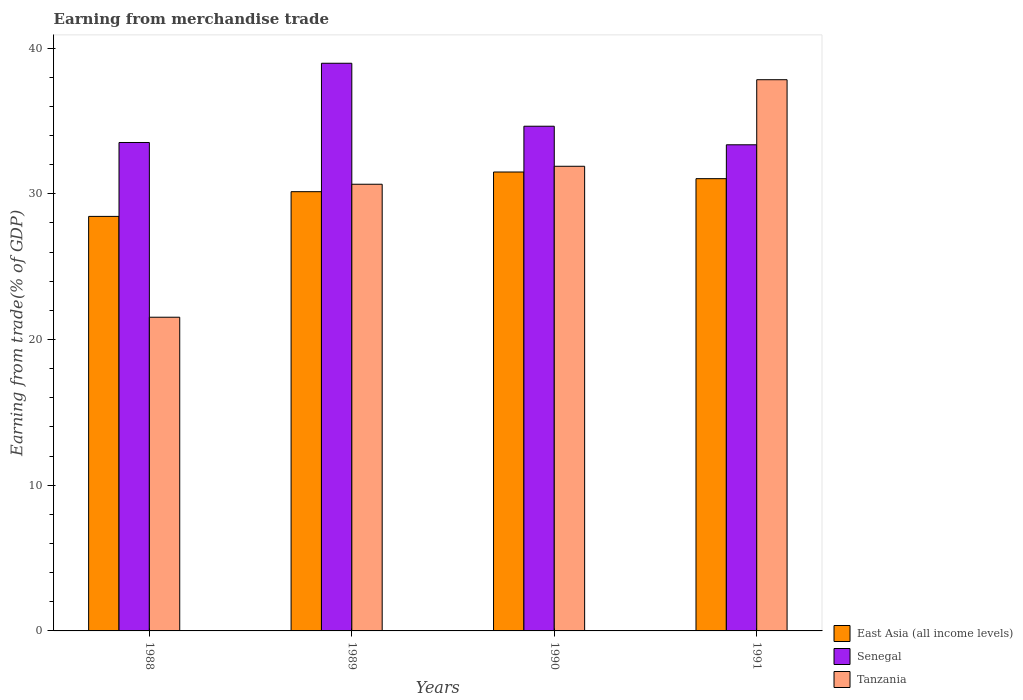How many different coloured bars are there?
Provide a succinct answer. 3. How many groups of bars are there?
Ensure brevity in your answer.  4. Are the number of bars per tick equal to the number of legend labels?
Your answer should be very brief. Yes. What is the earnings from trade in East Asia (all income levels) in 1991?
Ensure brevity in your answer.  31.04. Across all years, what is the maximum earnings from trade in East Asia (all income levels)?
Offer a terse response. 31.49. Across all years, what is the minimum earnings from trade in Tanzania?
Offer a terse response. 21.53. In which year was the earnings from trade in Senegal maximum?
Your answer should be very brief. 1989. What is the total earnings from trade in Senegal in the graph?
Offer a very short reply. 140.47. What is the difference between the earnings from trade in Senegal in 1988 and that in 1991?
Your answer should be compact. 0.16. What is the difference between the earnings from trade in Tanzania in 1991 and the earnings from trade in East Asia (all income levels) in 1990?
Your answer should be very brief. 6.33. What is the average earnings from trade in Senegal per year?
Your answer should be compact. 35.12. In the year 1988, what is the difference between the earnings from trade in East Asia (all income levels) and earnings from trade in Tanzania?
Make the answer very short. 6.92. What is the ratio of the earnings from trade in Senegal in 1988 to that in 1990?
Provide a short and direct response. 0.97. Is the difference between the earnings from trade in East Asia (all income levels) in 1988 and 1991 greater than the difference between the earnings from trade in Tanzania in 1988 and 1991?
Make the answer very short. Yes. What is the difference between the highest and the second highest earnings from trade in East Asia (all income levels)?
Your answer should be compact. 0.46. What is the difference between the highest and the lowest earnings from trade in Senegal?
Provide a succinct answer. 5.6. What does the 3rd bar from the left in 1988 represents?
Your response must be concise. Tanzania. What does the 3rd bar from the right in 1988 represents?
Ensure brevity in your answer.  East Asia (all income levels). Is it the case that in every year, the sum of the earnings from trade in Senegal and earnings from trade in Tanzania is greater than the earnings from trade in East Asia (all income levels)?
Ensure brevity in your answer.  Yes. How many years are there in the graph?
Keep it short and to the point. 4. What is the difference between two consecutive major ticks on the Y-axis?
Your response must be concise. 10. Does the graph contain grids?
Ensure brevity in your answer.  No. What is the title of the graph?
Offer a very short reply. Earning from merchandise trade. Does "European Union" appear as one of the legend labels in the graph?
Provide a succinct answer. No. What is the label or title of the X-axis?
Ensure brevity in your answer.  Years. What is the label or title of the Y-axis?
Give a very brief answer. Earning from trade(% of GDP). What is the Earning from trade(% of GDP) of East Asia (all income levels) in 1988?
Your answer should be very brief. 28.45. What is the Earning from trade(% of GDP) of Senegal in 1988?
Give a very brief answer. 33.52. What is the Earning from trade(% of GDP) in Tanzania in 1988?
Ensure brevity in your answer.  21.53. What is the Earning from trade(% of GDP) of East Asia (all income levels) in 1989?
Offer a terse response. 30.14. What is the Earning from trade(% of GDP) in Senegal in 1989?
Provide a succinct answer. 38.96. What is the Earning from trade(% of GDP) of Tanzania in 1989?
Ensure brevity in your answer.  30.65. What is the Earning from trade(% of GDP) in East Asia (all income levels) in 1990?
Your response must be concise. 31.49. What is the Earning from trade(% of GDP) in Senegal in 1990?
Make the answer very short. 34.64. What is the Earning from trade(% of GDP) of Tanzania in 1990?
Provide a succinct answer. 31.89. What is the Earning from trade(% of GDP) of East Asia (all income levels) in 1991?
Your answer should be very brief. 31.04. What is the Earning from trade(% of GDP) of Senegal in 1991?
Offer a very short reply. 33.36. What is the Earning from trade(% of GDP) in Tanzania in 1991?
Provide a succinct answer. 37.83. Across all years, what is the maximum Earning from trade(% of GDP) of East Asia (all income levels)?
Your response must be concise. 31.49. Across all years, what is the maximum Earning from trade(% of GDP) in Senegal?
Offer a terse response. 38.96. Across all years, what is the maximum Earning from trade(% of GDP) in Tanzania?
Make the answer very short. 37.83. Across all years, what is the minimum Earning from trade(% of GDP) in East Asia (all income levels)?
Provide a succinct answer. 28.45. Across all years, what is the minimum Earning from trade(% of GDP) of Senegal?
Keep it short and to the point. 33.36. Across all years, what is the minimum Earning from trade(% of GDP) in Tanzania?
Offer a very short reply. 21.53. What is the total Earning from trade(% of GDP) of East Asia (all income levels) in the graph?
Give a very brief answer. 121.12. What is the total Earning from trade(% of GDP) in Senegal in the graph?
Provide a succinct answer. 140.47. What is the total Earning from trade(% of GDP) in Tanzania in the graph?
Make the answer very short. 121.9. What is the difference between the Earning from trade(% of GDP) in East Asia (all income levels) in 1988 and that in 1989?
Your response must be concise. -1.7. What is the difference between the Earning from trade(% of GDP) of Senegal in 1988 and that in 1989?
Provide a succinct answer. -5.44. What is the difference between the Earning from trade(% of GDP) of Tanzania in 1988 and that in 1989?
Provide a succinct answer. -9.13. What is the difference between the Earning from trade(% of GDP) of East Asia (all income levels) in 1988 and that in 1990?
Ensure brevity in your answer.  -3.05. What is the difference between the Earning from trade(% of GDP) of Senegal in 1988 and that in 1990?
Your response must be concise. -1.12. What is the difference between the Earning from trade(% of GDP) in Tanzania in 1988 and that in 1990?
Make the answer very short. -10.36. What is the difference between the Earning from trade(% of GDP) in East Asia (all income levels) in 1988 and that in 1991?
Provide a succinct answer. -2.59. What is the difference between the Earning from trade(% of GDP) in Senegal in 1988 and that in 1991?
Your response must be concise. 0.16. What is the difference between the Earning from trade(% of GDP) in Tanzania in 1988 and that in 1991?
Offer a very short reply. -16.3. What is the difference between the Earning from trade(% of GDP) in East Asia (all income levels) in 1989 and that in 1990?
Ensure brevity in your answer.  -1.35. What is the difference between the Earning from trade(% of GDP) in Senegal in 1989 and that in 1990?
Provide a succinct answer. 4.32. What is the difference between the Earning from trade(% of GDP) of Tanzania in 1989 and that in 1990?
Offer a terse response. -1.23. What is the difference between the Earning from trade(% of GDP) in East Asia (all income levels) in 1989 and that in 1991?
Provide a succinct answer. -0.89. What is the difference between the Earning from trade(% of GDP) of Senegal in 1989 and that in 1991?
Your answer should be compact. 5.6. What is the difference between the Earning from trade(% of GDP) in Tanzania in 1989 and that in 1991?
Offer a very short reply. -7.17. What is the difference between the Earning from trade(% of GDP) in East Asia (all income levels) in 1990 and that in 1991?
Your answer should be compact. 0.46. What is the difference between the Earning from trade(% of GDP) of Senegal in 1990 and that in 1991?
Give a very brief answer. 1.27. What is the difference between the Earning from trade(% of GDP) of Tanzania in 1990 and that in 1991?
Your answer should be very brief. -5.94. What is the difference between the Earning from trade(% of GDP) in East Asia (all income levels) in 1988 and the Earning from trade(% of GDP) in Senegal in 1989?
Keep it short and to the point. -10.51. What is the difference between the Earning from trade(% of GDP) in East Asia (all income levels) in 1988 and the Earning from trade(% of GDP) in Tanzania in 1989?
Offer a terse response. -2.21. What is the difference between the Earning from trade(% of GDP) of Senegal in 1988 and the Earning from trade(% of GDP) of Tanzania in 1989?
Offer a very short reply. 2.86. What is the difference between the Earning from trade(% of GDP) in East Asia (all income levels) in 1988 and the Earning from trade(% of GDP) in Senegal in 1990?
Make the answer very short. -6.19. What is the difference between the Earning from trade(% of GDP) in East Asia (all income levels) in 1988 and the Earning from trade(% of GDP) in Tanzania in 1990?
Provide a succinct answer. -3.44. What is the difference between the Earning from trade(% of GDP) of Senegal in 1988 and the Earning from trade(% of GDP) of Tanzania in 1990?
Offer a terse response. 1.63. What is the difference between the Earning from trade(% of GDP) in East Asia (all income levels) in 1988 and the Earning from trade(% of GDP) in Senegal in 1991?
Ensure brevity in your answer.  -4.91. What is the difference between the Earning from trade(% of GDP) in East Asia (all income levels) in 1988 and the Earning from trade(% of GDP) in Tanzania in 1991?
Offer a very short reply. -9.38. What is the difference between the Earning from trade(% of GDP) of Senegal in 1988 and the Earning from trade(% of GDP) of Tanzania in 1991?
Offer a terse response. -4.31. What is the difference between the Earning from trade(% of GDP) of East Asia (all income levels) in 1989 and the Earning from trade(% of GDP) of Senegal in 1990?
Your response must be concise. -4.49. What is the difference between the Earning from trade(% of GDP) in East Asia (all income levels) in 1989 and the Earning from trade(% of GDP) in Tanzania in 1990?
Make the answer very short. -1.74. What is the difference between the Earning from trade(% of GDP) in Senegal in 1989 and the Earning from trade(% of GDP) in Tanzania in 1990?
Offer a very short reply. 7.07. What is the difference between the Earning from trade(% of GDP) in East Asia (all income levels) in 1989 and the Earning from trade(% of GDP) in Senegal in 1991?
Your answer should be compact. -3.22. What is the difference between the Earning from trade(% of GDP) in East Asia (all income levels) in 1989 and the Earning from trade(% of GDP) in Tanzania in 1991?
Offer a terse response. -7.68. What is the difference between the Earning from trade(% of GDP) of Senegal in 1989 and the Earning from trade(% of GDP) of Tanzania in 1991?
Offer a very short reply. 1.13. What is the difference between the Earning from trade(% of GDP) in East Asia (all income levels) in 1990 and the Earning from trade(% of GDP) in Senegal in 1991?
Ensure brevity in your answer.  -1.87. What is the difference between the Earning from trade(% of GDP) of East Asia (all income levels) in 1990 and the Earning from trade(% of GDP) of Tanzania in 1991?
Your answer should be compact. -6.33. What is the difference between the Earning from trade(% of GDP) of Senegal in 1990 and the Earning from trade(% of GDP) of Tanzania in 1991?
Your answer should be very brief. -3.19. What is the average Earning from trade(% of GDP) of East Asia (all income levels) per year?
Provide a succinct answer. 30.28. What is the average Earning from trade(% of GDP) in Senegal per year?
Your response must be concise. 35.12. What is the average Earning from trade(% of GDP) in Tanzania per year?
Your response must be concise. 30.47. In the year 1988, what is the difference between the Earning from trade(% of GDP) of East Asia (all income levels) and Earning from trade(% of GDP) of Senegal?
Your answer should be very brief. -5.07. In the year 1988, what is the difference between the Earning from trade(% of GDP) of East Asia (all income levels) and Earning from trade(% of GDP) of Tanzania?
Make the answer very short. 6.92. In the year 1988, what is the difference between the Earning from trade(% of GDP) in Senegal and Earning from trade(% of GDP) in Tanzania?
Your answer should be very brief. 11.99. In the year 1989, what is the difference between the Earning from trade(% of GDP) of East Asia (all income levels) and Earning from trade(% of GDP) of Senegal?
Your answer should be compact. -8.81. In the year 1989, what is the difference between the Earning from trade(% of GDP) in East Asia (all income levels) and Earning from trade(% of GDP) in Tanzania?
Offer a terse response. -0.51. In the year 1989, what is the difference between the Earning from trade(% of GDP) in Senegal and Earning from trade(% of GDP) in Tanzania?
Give a very brief answer. 8.3. In the year 1990, what is the difference between the Earning from trade(% of GDP) of East Asia (all income levels) and Earning from trade(% of GDP) of Senegal?
Offer a very short reply. -3.14. In the year 1990, what is the difference between the Earning from trade(% of GDP) of East Asia (all income levels) and Earning from trade(% of GDP) of Tanzania?
Ensure brevity in your answer.  -0.39. In the year 1990, what is the difference between the Earning from trade(% of GDP) in Senegal and Earning from trade(% of GDP) in Tanzania?
Keep it short and to the point. 2.75. In the year 1991, what is the difference between the Earning from trade(% of GDP) of East Asia (all income levels) and Earning from trade(% of GDP) of Senegal?
Give a very brief answer. -2.32. In the year 1991, what is the difference between the Earning from trade(% of GDP) in East Asia (all income levels) and Earning from trade(% of GDP) in Tanzania?
Provide a succinct answer. -6.79. In the year 1991, what is the difference between the Earning from trade(% of GDP) in Senegal and Earning from trade(% of GDP) in Tanzania?
Offer a very short reply. -4.47. What is the ratio of the Earning from trade(% of GDP) in East Asia (all income levels) in 1988 to that in 1989?
Provide a succinct answer. 0.94. What is the ratio of the Earning from trade(% of GDP) in Senegal in 1988 to that in 1989?
Give a very brief answer. 0.86. What is the ratio of the Earning from trade(% of GDP) of Tanzania in 1988 to that in 1989?
Your answer should be very brief. 0.7. What is the ratio of the Earning from trade(% of GDP) of East Asia (all income levels) in 1988 to that in 1990?
Your answer should be compact. 0.9. What is the ratio of the Earning from trade(% of GDP) of Senegal in 1988 to that in 1990?
Make the answer very short. 0.97. What is the ratio of the Earning from trade(% of GDP) of Tanzania in 1988 to that in 1990?
Your answer should be very brief. 0.68. What is the ratio of the Earning from trade(% of GDP) of East Asia (all income levels) in 1988 to that in 1991?
Keep it short and to the point. 0.92. What is the ratio of the Earning from trade(% of GDP) of Tanzania in 1988 to that in 1991?
Provide a succinct answer. 0.57. What is the ratio of the Earning from trade(% of GDP) in East Asia (all income levels) in 1989 to that in 1990?
Keep it short and to the point. 0.96. What is the ratio of the Earning from trade(% of GDP) of Senegal in 1989 to that in 1990?
Offer a terse response. 1.12. What is the ratio of the Earning from trade(% of GDP) of Tanzania in 1989 to that in 1990?
Provide a succinct answer. 0.96. What is the ratio of the Earning from trade(% of GDP) of East Asia (all income levels) in 1989 to that in 1991?
Your response must be concise. 0.97. What is the ratio of the Earning from trade(% of GDP) in Senegal in 1989 to that in 1991?
Give a very brief answer. 1.17. What is the ratio of the Earning from trade(% of GDP) in Tanzania in 1989 to that in 1991?
Keep it short and to the point. 0.81. What is the ratio of the Earning from trade(% of GDP) in East Asia (all income levels) in 1990 to that in 1991?
Provide a short and direct response. 1.01. What is the ratio of the Earning from trade(% of GDP) in Senegal in 1990 to that in 1991?
Provide a short and direct response. 1.04. What is the ratio of the Earning from trade(% of GDP) in Tanzania in 1990 to that in 1991?
Provide a short and direct response. 0.84. What is the difference between the highest and the second highest Earning from trade(% of GDP) in East Asia (all income levels)?
Provide a short and direct response. 0.46. What is the difference between the highest and the second highest Earning from trade(% of GDP) of Senegal?
Your answer should be compact. 4.32. What is the difference between the highest and the second highest Earning from trade(% of GDP) of Tanzania?
Your answer should be compact. 5.94. What is the difference between the highest and the lowest Earning from trade(% of GDP) in East Asia (all income levels)?
Make the answer very short. 3.05. What is the difference between the highest and the lowest Earning from trade(% of GDP) of Senegal?
Keep it short and to the point. 5.6. What is the difference between the highest and the lowest Earning from trade(% of GDP) in Tanzania?
Your answer should be compact. 16.3. 